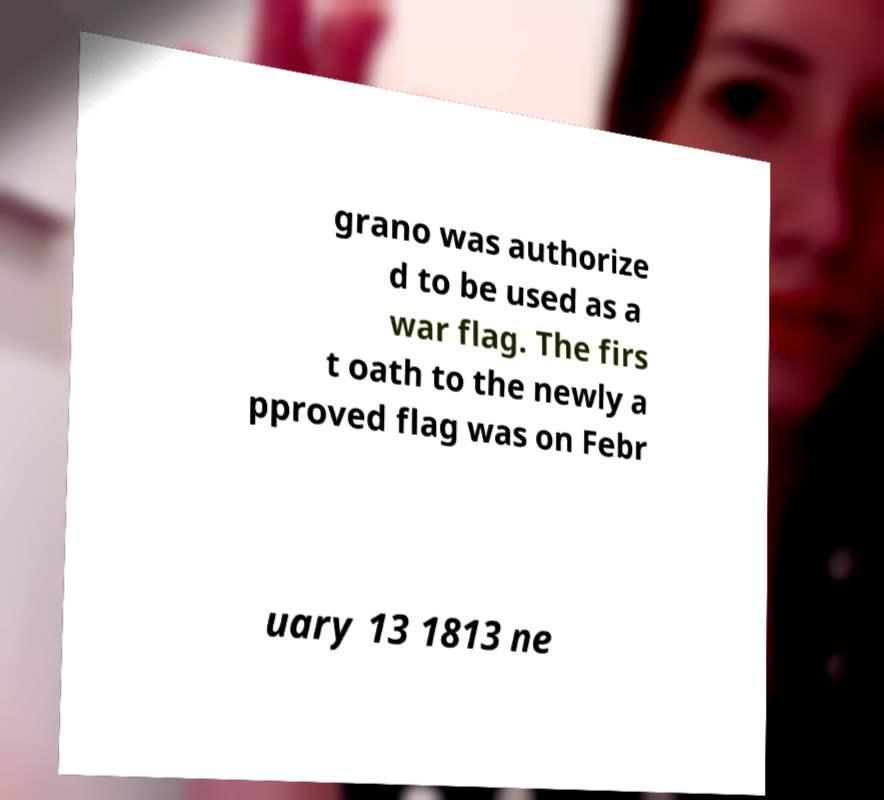For documentation purposes, I need the text within this image transcribed. Could you provide that? grano was authorize d to be used as a war flag. The firs t oath to the newly a pproved flag was on Febr uary 13 1813 ne 